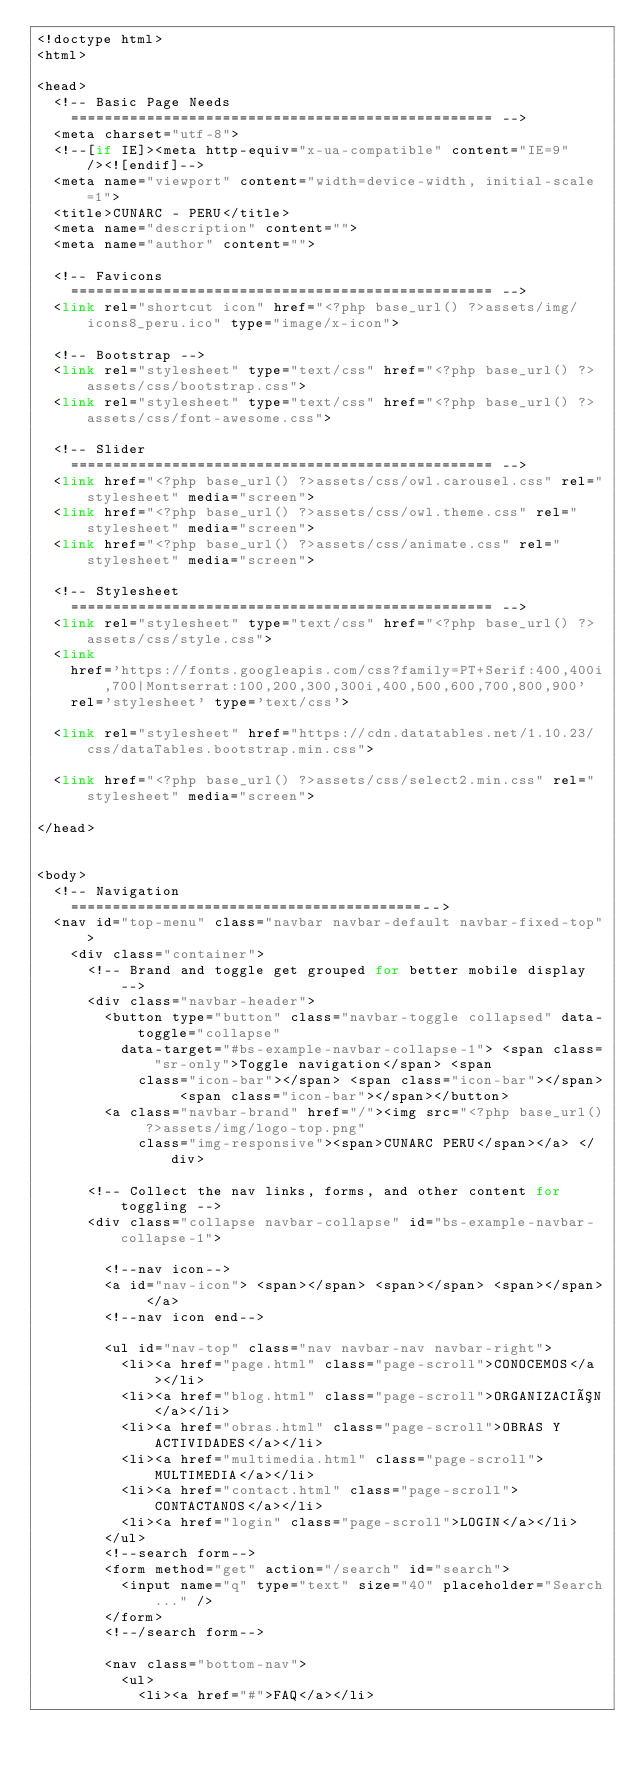<code> <loc_0><loc_0><loc_500><loc_500><_PHP_><!doctype html>
<html>

<head>
	<!-- Basic Page Needs
    ================================================== -->
	<meta charset="utf-8">
	<!--[if IE]><meta http-equiv="x-ua-compatible" content="IE=9" /><![endif]-->
	<meta name="viewport" content="width=device-width, initial-scale=1">
	<title>CUNARC - PERU</title>
	<meta name="description" content="">
	<meta name="author" content="">

	<!-- Favicons
    ================================================== -->
	<link rel="shortcut icon" href="<?php base_url() ?>assets/img/icons8_peru.ico" type="image/x-icon">

	<!-- Bootstrap -->
	<link rel="stylesheet" type="text/css" href="<?php base_url() ?>assets/css/bootstrap.css">
	<link rel="stylesheet" type="text/css" href="<?php base_url() ?>assets/css/font-awesome.css">

	<!-- Slider
    ================================================== -->
	<link href="<?php base_url() ?>assets/css/owl.carousel.css" rel="stylesheet" media="screen">
	<link href="<?php base_url() ?>assets/css/owl.theme.css" rel="stylesheet" media="screen">
	<link href="<?php base_url() ?>assets/css/animate.css" rel="stylesheet" media="screen">

	<!-- Stylesheet
    ================================================== -->
	<link rel="stylesheet" type="text/css" href="<?php base_url() ?>assets/css/style.css">
	<link
		href='https://fonts.googleapis.com/css?family=PT+Serif:400,400i,700|Montserrat:100,200,300,300i,400,500,600,700,800,900'
		rel='stylesheet' type='text/css'>

	<link rel="stylesheet" href="https://cdn.datatables.net/1.10.23/css/dataTables.bootstrap.min.css">

	<link href="<?php base_url() ?>assets/css/select2.min.css" rel="stylesheet" media="screen">

</head>


<body>
	<!-- Navigation
    ==========================================-->
	<nav id="top-menu" class="navbar navbar-default navbar-fixed-top">
		<div class="container">
			<!-- Brand and toggle get grouped for better mobile display -->
			<div class="navbar-header">
				<button type="button" class="navbar-toggle collapsed" data-toggle="collapse"
					data-target="#bs-example-navbar-collapse-1"> <span class="sr-only">Toggle navigation</span> <span
						class="icon-bar"></span> <span class="icon-bar"></span> <span class="icon-bar"></span></button>
				<a class="navbar-brand" href="/"><img src="<?php base_url() ?>assets/img/logo-top.png"
						class="img-responsive"><span>CUNARC PERU</span></a> </div>

			<!-- Collect the nav links, forms, and other content for toggling -->
			<div class="collapse navbar-collapse" id="bs-example-navbar-collapse-1">

				<!--nav icon-->
				<a id="nav-icon"> <span></span> <span></span> <span></span> </a>
				<!--nav icon end-->

				<ul id="nav-top" class="nav navbar-nav navbar-right">
					<li><a href="page.html" class="page-scroll">CONOCEMOS</a></li>
					<li><a href="blog.html" class="page-scroll">ORGANIZACIÓN</a></li>
					<li><a href="obras.html" class="page-scroll">OBRAS Y ACTIVIDADES</a></li>
					<li><a href="multimedia.html" class="page-scroll">MULTIMEDIA</a></li>
					<li><a href="contact.html" class="page-scroll">CONTACTANOS</a></li>
					<li><a href="login" class="page-scroll">LOGIN</a></li>
				</ul>
				<!--search form-->
				<form method="get" action="/search" id="search">
					<input name="q" type="text" size="40" placeholder="Search..." />
				</form>
				<!--/search form-->

				<nav class="bottom-nav">
					<ul>
						<li><a href="#">FAQ</a></li></code> 